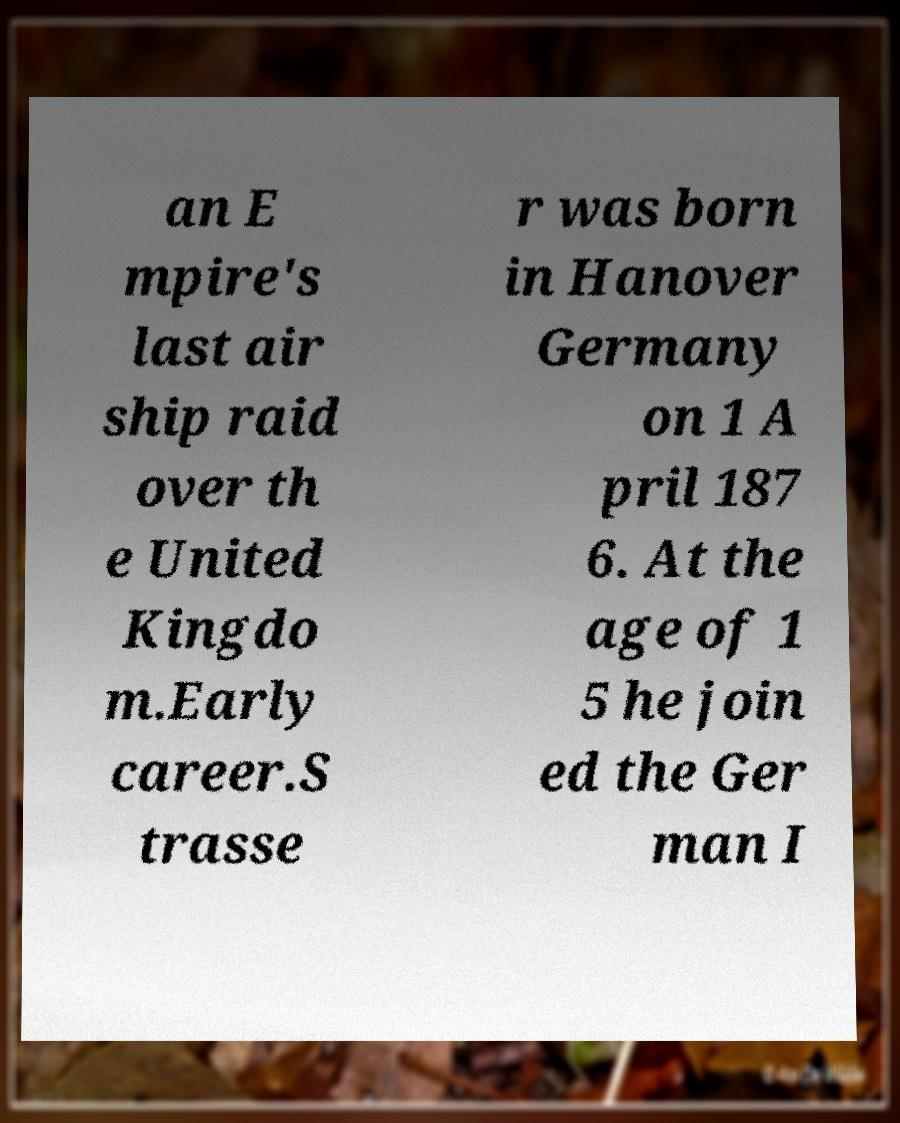For documentation purposes, I need the text within this image transcribed. Could you provide that? an E mpire's last air ship raid over th e United Kingdo m.Early career.S trasse r was born in Hanover Germany on 1 A pril 187 6. At the age of 1 5 he join ed the Ger man I 